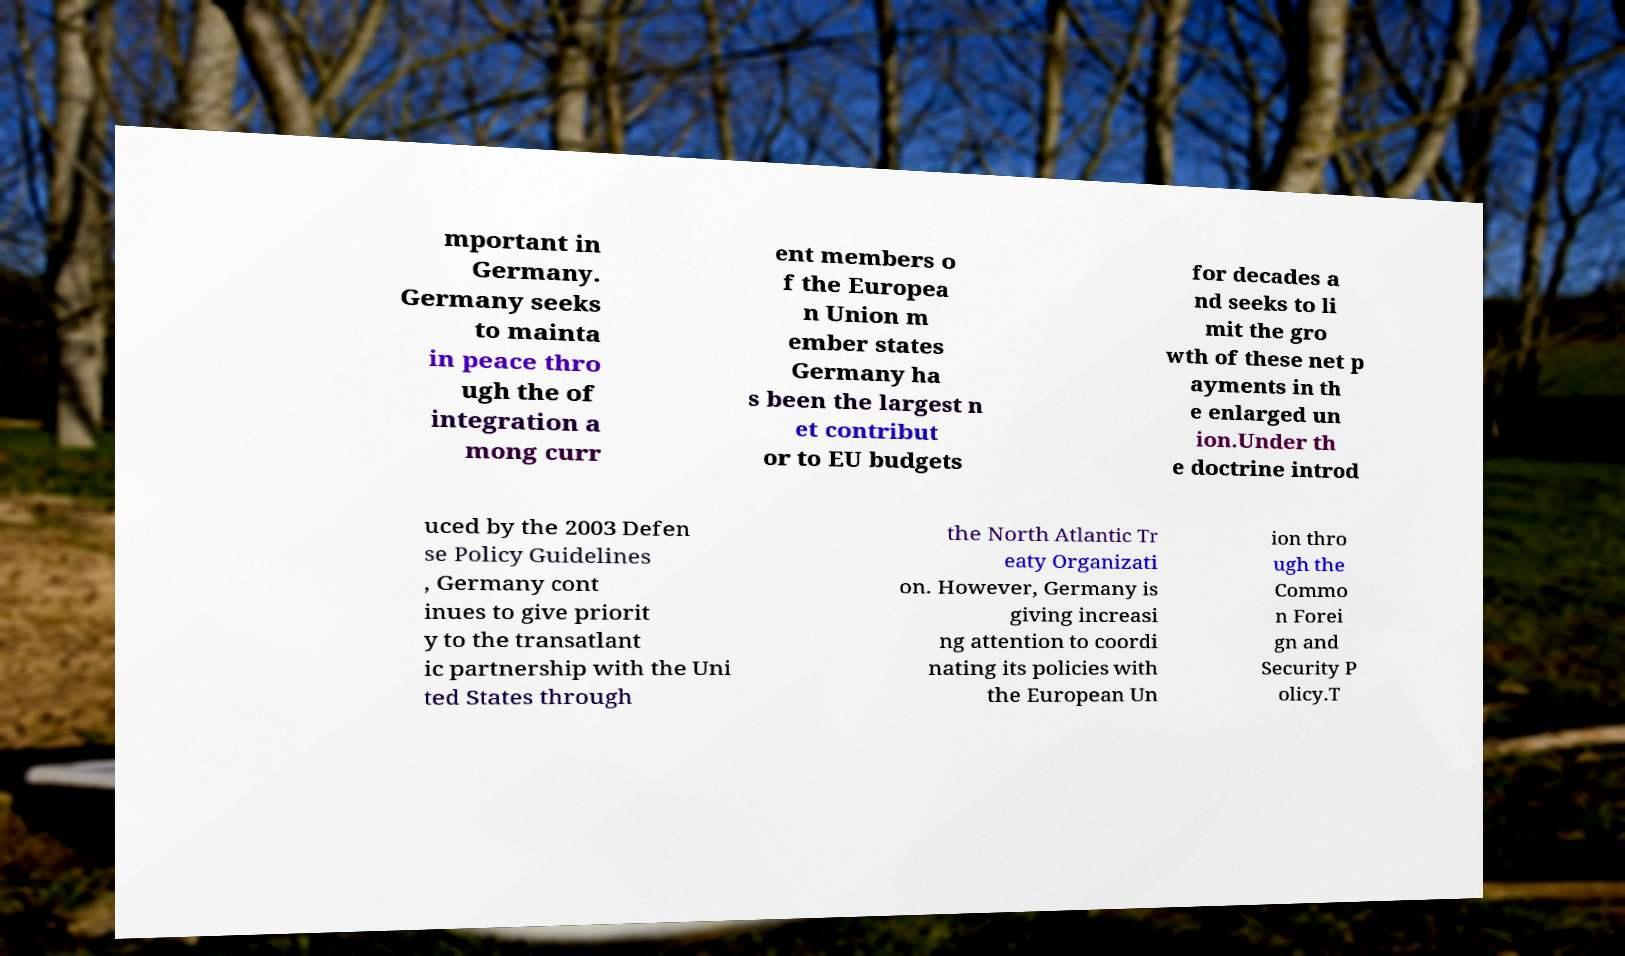Can you accurately transcribe the text from the provided image for me? mportant in Germany. Germany seeks to mainta in peace thro ugh the of integration a mong curr ent members o f the Europea n Union m ember states Germany ha s been the largest n et contribut or to EU budgets for decades a nd seeks to li mit the gro wth of these net p ayments in th e enlarged un ion.Under th e doctrine introd uced by the 2003 Defen se Policy Guidelines , Germany cont inues to give priorit y to the transatlant ic partnership with the Uni ted States through the North Atlantic Tr eaty Organizati on. However, Germany is giving increasi ng attention to coordi nating its policies with the European Un ion thro ugh the Commo n Forei gn and Security P olicy.T 